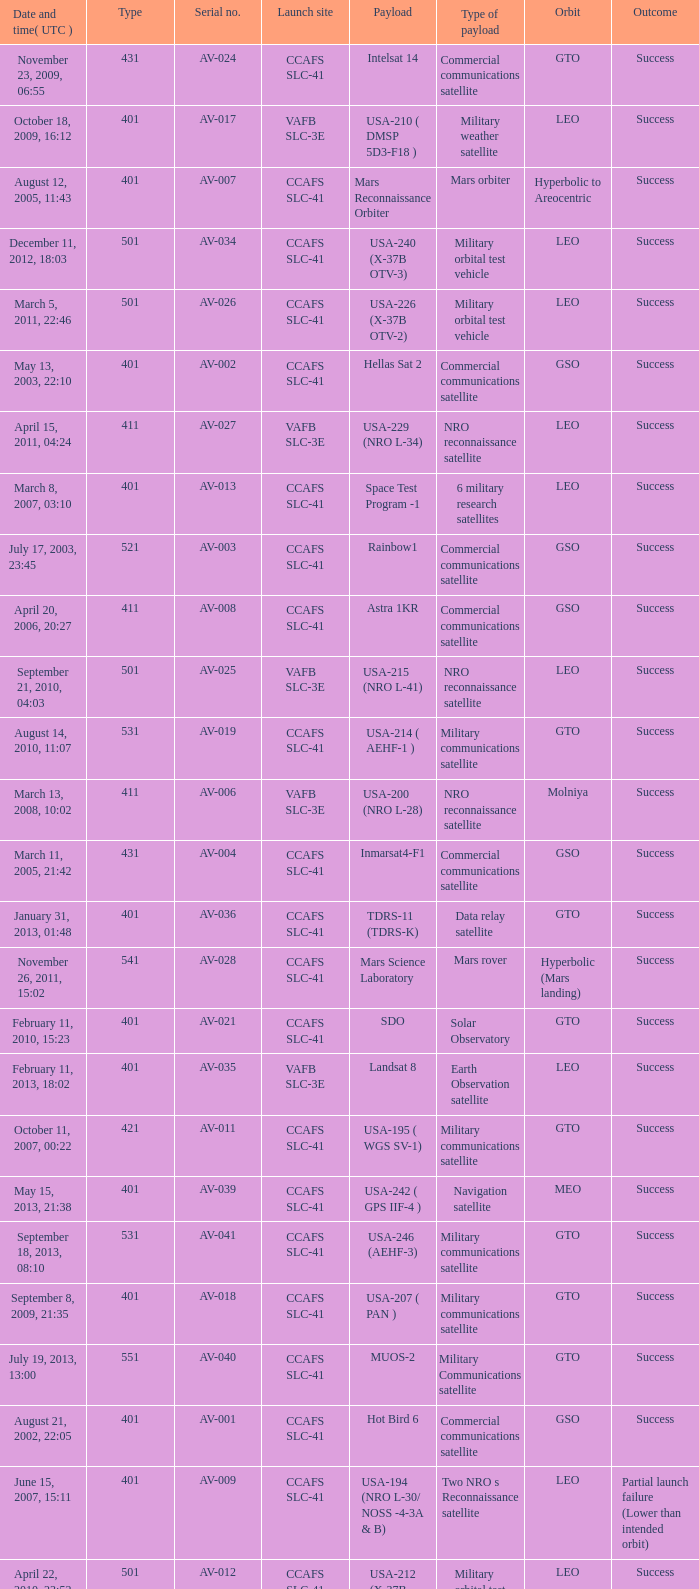When was the payload of Commercial Communications Satellite amc16? December 17, 2004, 12:07. 